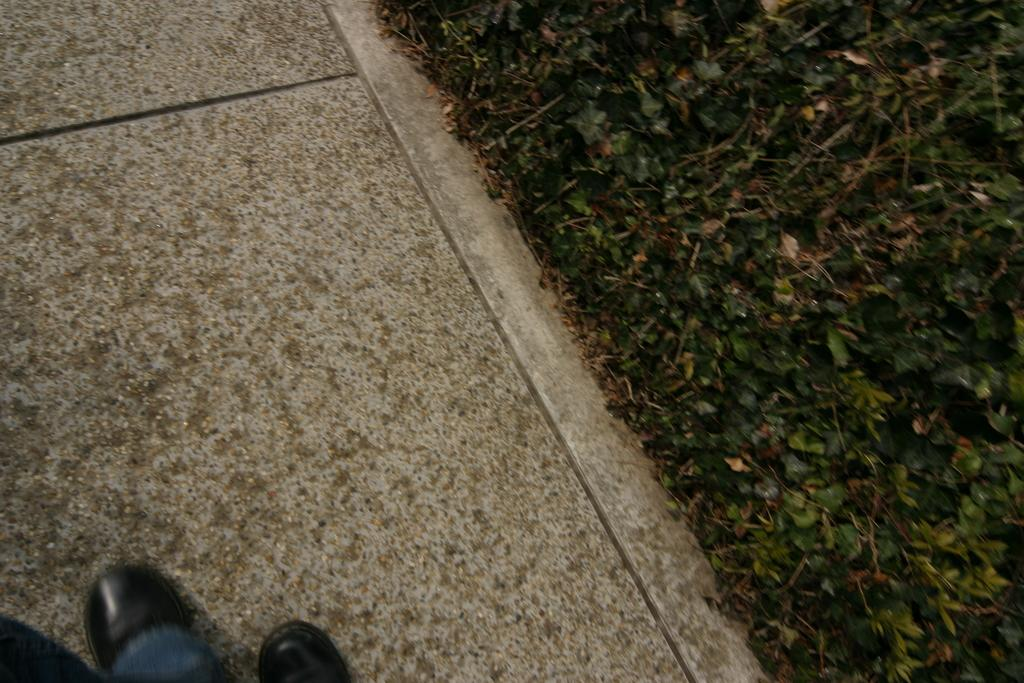What can be seen on the left side of the image? There is a footpath on the left side of the image. What is visible on the footpath? There are persons' legs visible on the footpath. What type of vegetation is on the right side of the image? There are plants on the right side of the image. Can you tell me how many trucks are parked near the footpath in the image? There is no truck present in the image; it only features a footpath and plants. Are there any houses visible in the image? There is no mention of houses in the provided facts, and none are visible in the image. 